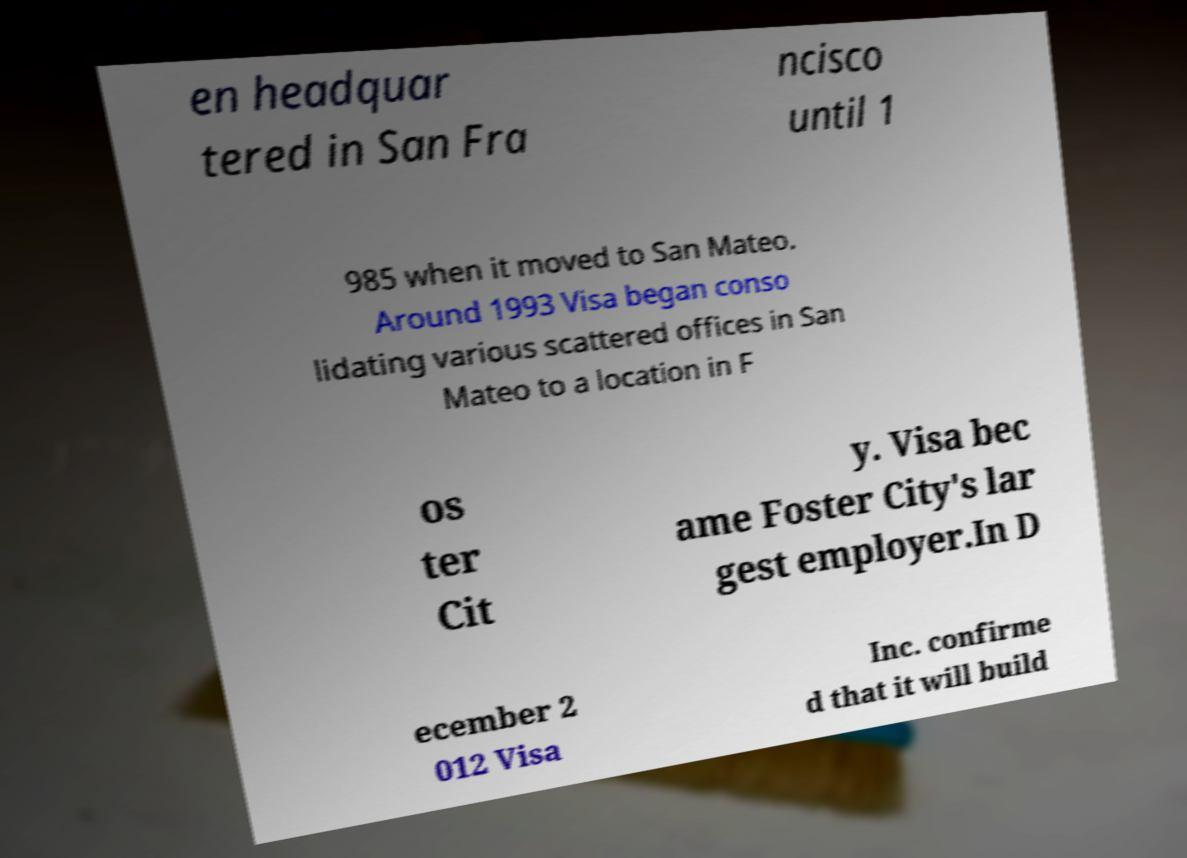Can you accurately transcribe the text from the provided image for me? en headquar tered in San Fra ncisco until 1 985 when it moved to San Mateo. Around 1993 Visa began conso lidating various scattered offices in San Mateo to a location in F os ter Cit y. Visa bec ame Foster City's lar gest employer.In D ecember 2 012 Visa Inc. confirme d that it will build 